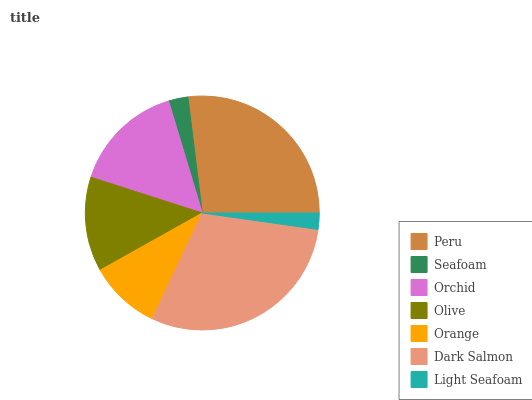Is Light Seafoam the minimum?
Answer yes or no. Yes. Is Dark Salmon the maximum?
Answer yes or no. Yes. Is Seafoam the minimum?
Answer yes or no. No. Is Seafoam the maximum?
Answer yes or no. No. Is Peru greater than Seafoam?
Answer yes or no. Yes. Is Seafoam less than Peru?
Answer yes or no. Yes. Is Seafoam greater than Peru?
Answer yes or no. No. Is Peru less than Seafoam?
Answer yes or no. No. Is Olive the high median?
Answer yes or no. Yes. Is Olive the low median?
Answer yes or no. Yes. Is Orchid the high median?
Answer yes or no. No. Is Orchid the low median?
Answer yes or no. No. 